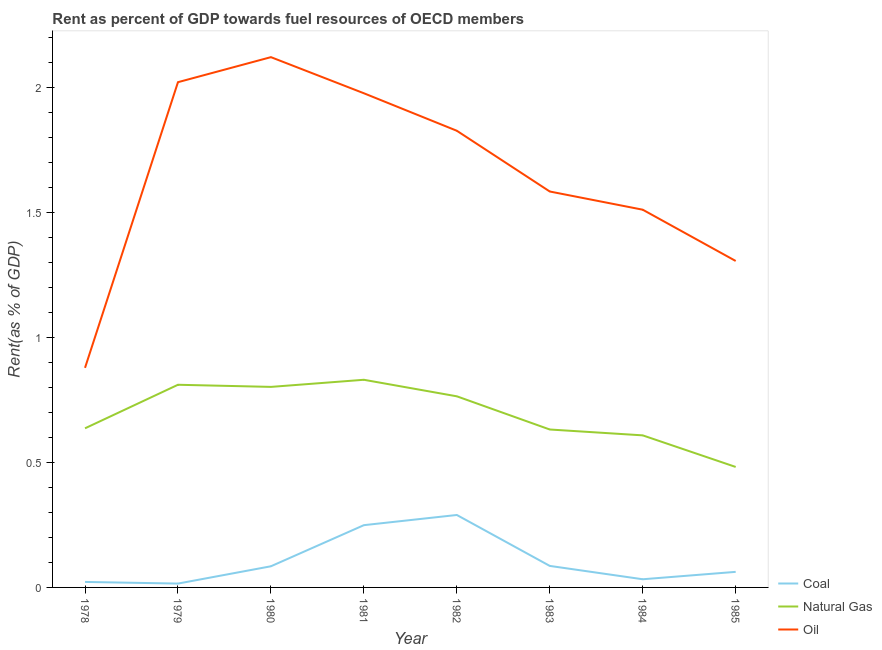Is the number of lines equal to the number of legend labels?
Offer a very short reply. Yes. What is the rent towards oil in 1979?
Offer a terse response. 2.02. Across all years, what is the maximum rent towards coal?
Offer a terse response. 0.29. Across all years, what is the minimum rent towards natural gas?
Give a very brief answer. 0.48. In which year was the rent towards coal minimum?
Ensure brevity in your answer.  1979. What is the total rent towards oil in the graph?
Give a very brief answer. 13.23. What is the difference between the rent towards coal in 1980 and that in 1982?
Provide a short and direct response. -0.21. What is the difference between the rent towards oil in 1980 and the rent towards natural gas in 1979?
Make the answer very short. 1.31. What is the average rent towards coal per year?
Keep it short and to the point. 0.11. In the year 1982, what is the difference between the rent towards coal and rent towards oil?
Give a very brief answer. -1.54. In how many years, is the rent towards natural gas greater than 0.4 %?
Your answer should be very brief. 8. What is the ratio of the rent towards natural gas in 1979 to that in 1981?
Offer a very short reply. 0.98. Is the rent towards natural gas in 1980 less than that in 1985?
Ensure brevity in your answer.  No. Is the difference between the rent towards oil in 1981 and 1983 greater than the difference between the rent towards natural gas in 1981 and 1983?
Offer a very short reply. Yes. What is the difference between the highest and the second highest rent towards coal?
Ensure brevity in your answer.  0.04. What is the difference between the highest and the lowest rent towards oil?
Keep it short and to the point. 1.24. In how many years, is the rent towards oil greater than the average rent towards oil taken over all years?
Your answer should be very brief. 4. Is the sum of the rent towards oil in 1980 and 1982 greater than the maximum rent towards coal across all years?
Your response must be concise. Yes. Is the rent towards oil strictly less than the rent towards natural gas over the years?
Your answer should be compact. No. How many lines are there?
Give a very brief answer. 3. What is the difference between two consecutive major ticks on the Y-axis?
Your answer should be compact. 0.5. Does the graph contain grids?
Your answer should be very brief. No. Where does the legend appear in the graph?
Ensure brevity in your answer.  Bottom right. How many legend labels are there?
Provide a succinct answer. 3. How are the legend labels stacked?
Make the answer very short. Vertical. What is the title of the graph?
Keep it short and to the point. Rent as percent of GDP towards fuel resources of OECD members. Does "Travel services" appear as one of the legend labels in the graph?
Ensure brevity in your answer.  No. What is the label or title of the Y-axis?
Offer a terse response. Rent(as % of GDP). What is the Rent(as % of GDP) of Coal in 1978?
Your answer should be compact. 0.02. What is the Rent(as % of GDP) of Natural Gas in 1978?
Your answer should be compact. 0.64. What is the Rent(as % of GDP) of Oil in 1978?
Ensure brevity in your answer.  0.88. What is the Rent(as % of GDP) of Coal in 1979?
Offer a terse response. 0.02. What is the Rent(as % of GDP) in Natural Gas in 1979?
Offer a terse response. 0.81. What is the Rent(as % of GDP) of Oil in 1979?
Your answer should be compact. 2.02. What is the Rent(as % of GDP) of Coal in 1980?
Offer a terse response. 0.08. What is the Rent(as % of GDP) of Natural Gas in 1980?
Provide a succinct answer. 0.8. What is the Rent(as % of GDP) of Oil in 1980?
Give a very brief answer. 2.12. What is the Rent(as % of GDP) of Coal in 1981?
Make the answer very short. 0.25. What is the Rent(as % of GDP) of Natural Gas in 1981?
Provide a short and direct response. 0.83. What is the Rent(as % of GDP) of Oil in 1981?
Provide a succinct answer. 1.98. What is the Rent(as % of GDP) of Coal in 1982?
Your answer should be compact. 0.29. What is the Rent(as % of GDP) in Natural Gas in 1982?
Your answer should be very brief. 0.76. What is the Rent(as % of GDP) of Oil in 1982?
Give a very brief answer. 1.83. What is the Rent(as % of GDP) in Coal in 1983?
Offer a very short reply. 0.09. What is the Rent(as % of GDP) in Natural Gas in 1983?
Ensure brevity in your answer.  0.63. What is the Rent(as % of GDP) of Oil in 1983?
Keep it short and to the point. 1.58. What is the Rent(as % of GDP) of Coal in 1984?
Your response must be concise. 0.03. What is the Rent(as % of GDP) of Natural Gas in 1984?
Your answer should be very brief. 0.61. What is the Rent(as % of GDP) in Oil in 1984?
Keep it short and to the point. 1.51. What is the Rent(as % of GDP) in Coal in 1985?
Make the answer very short. 0.06. What is the Rent(as % of GDP) in Natural Gas in 1985?
Your answer should be very brief. 0.48. What is the Rent(as % of GDP) of Oil in 1985?
Provide a short and direct response. 1.31. Across all years, what is the maximum Rent(as % of GDP) of Coal?
Make the answer very short. 0.29. Across all years, what is the maximum Rent(as % of GDP) in Natural Gas?
Provide a short and direct response. 0.83. Across all years, what is the maximum Rent(as % of GDP) of Oil?
Provide a succinct answer. 2.12. Across all years, what is the minimum Rent(as % of GDP) of Coal?
Your response must be concise. 0.02. Across all years, what is the minimum Rent(as % of GDP) of Natural Gas?
Make the answer very short. 0.48. Across all years, what is the minimum Rent(as % of GDP) in Oil?
Make the answer very short. 0.88. What is the total Rent(as % of GDP) in Coal in the graph?
Ensure brevity in your answer.  0.84. What is the total Rent(as % of GDP) of Natural Gas in the graph?
Provide a succinct answer. 5.57. What is the total Rent(as % of GDP) of Oil in the graph?
Provide a succinct answer. 13.23. What is the difference between the Rent(as % of GDP) in Coal in 1978 and that in 1979?
Make the answer very short. 0.01. What is the difference between the Rent(as % of GDP) of Natural Gas in 1978 and that in 1979?
Ensure brevity in your answer.  -0.17. What is the difference between the Rent(as % of GDP) of Oil in 1978 and that in 1979?
Provide a short and direct response. -1.14. What is the difference between the Rent(as % of GDP) in Coal in 1978 and that in 1980?
Your answer should be very brief. -0.06. What is the difference between the Rent(as % of GDP) in Natural Gas in 1978 and that in 1980?
Ensure brevity in your answer.  -0.17. What is the difference between the Rent(as % of GDP) of Oil in 1978 and that in 1980?
Offer a very short reply. -1.24. What is the difference between the Rent(as % of GDP) in Coal in 1978 and that in 1981?
Provide a short and direct response. -0.23. What is the difference between the Rent(as % of GDP) in Natural Gas in 1978 and that in 1981?
Your answer should be very brief. -0.19. What is the difference between the Rent(as % of GDP) in Oil in 1978 and that in 1981?
Your response must be concise. -1.1. What is the difference between the Rent(as % of GDP) in Coal in 1978 and that in 1982?
Make the answer very short. -0.27. What is the difference between the Rent(as % of GDP) of Natural Gas in 1978 and that in 1982?
Your response must be concise. -0.13. What is the difference between the Rent(as % of GDP) in Oil in 1978 and that in 1982?
Offer a very short reply. -0.95. What is the difference between the Rent(as % of GDP) of Coal in 1978 and that in 1983?
Offer a very short reply. -0.06. What is the difference between the Rent(as % of GDP) of Natural Gas in 1978 and that in 1983?
Give a very brief answer. 0. What is the difference between the Rent(as % of GDP) in Oil in 1978 and that in 1983?
Keep it short and to the point. -0.71. What is the difference between the Rent(as % of GDP) in Coal in 1978 and that in 1984?
Give a very brief answer. -0.01. What is the difference between the Rent(as % of GDP) of Natural Gas in 1978 and that in 1984?
Make the answer very short. 0.03. What is the difference between the Rent(as % of GDP) of Oil in 1978 and that in 1984?
Provide a short and direct response. -0.63. What is the difference between the Rent(as % of GDP) in Coal in 1978 and that in 1985?
Give a very brief answer. -0.04. What is the difference between the Rent(as % of GDP) in Natural Gas in 1978 and that in 1985?
Provide a short and direct response. 0.15. What is the difference between the Rent(as % of GDP) of Oil in 1978 and that in 1985?
Keep it short and to the point. -0.43. What is the difference between the Rent(as % of GDP) in Coal in 1979 and that in 1980?
Keep it short and to the point. -0.07. What is the difference between the Rent(as % of GDP) of Natural Gas in 1979 and that in 1980?
Offer a very short reply. 0.01. What is the difference between the Rent(as % of GDP) of Oil in 1979 and that in 1980?
Keep it short and to the point. -0.1. What is the difference between the Rent(as % of GDP) in Coal in 1979 and that in 1981?
Your answer should be very brief. -0.23. What is the difference between the Rent(as % of GDP) of Natural Gas in 1979 and that in 1981?
Keep it short and to the point. -0.02. What is the difference between the Rent(as % of GDP) in Oil in 1979 and that in 1981?
Provide a short and direct response. 0.04. What is the difference between the Rent(as % of GDP) of Coal in 1979 and that in 1982?
Your response must be concise. -0.27. What is the difference between the Rent(as % of GDP) of Natural Gas in 1979 and that in 1982?
Your response must be concise. 0.05. What is the difference between the Rent(as % of GDP) in Oil in 1979 and that in 1982?
Offer a very short reply. 0.19. What is the difference between the Rent(as % of GDP) in Coal in 1979 and that in 1983?
Give a very brief answer. -0.07. What is the difference between the Rent(as % of GDP) in Natural Gas in 1979 and that in 1983?
Your response must be concise. 0.18. What is the difference between the Rent(as % of GDP) of Oil in 1979 and that in 1983?
Provide a succinct answer. 0.44. What is the difference between the Rent(as % of GDP) of Coal in 1979 and that in 1984?
Offer a terse response. -0.02. What is the difference between the Rent(as % of GDP) of Natural Gas in 1979 and that in 1984?
Your answer should be very brief. 0.2. What is the difference between the Rent(as % of GDP) of Oil in 1979 and that in 1984?
Make the answer very short. 0.51. What is the difference between the Rent(as % of GDP) in Coal in 1979 and that in 1985?
Your response must be concise. -0.05. What is the difference between the Rent(as % of GDP) in Natural Gas in 1979 and that in 1985?
Provide a succinct answer. 0.33. What is the difference between the Rent(as % of GDP) of Oil in 1979 and that in 1985?
Provide a short and direct response. 0.72. What is the difference between the Rent(as % of GDP) in Coal in 1980 and that in 1981?
Make the answer very short. -0.16. What is the difference between the Rent(as % of GDP) of Natural Gas in 1980 and that in 1981?
Your answer should be compact. -0.03. What is the difference between the Rent(as % of GDP) in Oil in 1980 and that in 1981?
Your response must be concise. 0.14. What is the difference between the Rent(as % of GDP) of Coal in 1980 and that in 1982?
Provide a short and direct response. -0.21. What is the difference between the Rent(as % of GDP) of Natural Gas in 1980 and that in 1982?
Ensure brevity in your answer.  0.04. What is the difference between the Rent(as % of GDP) of Oil in 1980 and that in 1982?
Offer a very short reply. 0.29. What is the difference between the Rent(as % of GDP) in Coal in 1980 and that in 1983?
Make the answer very short. -0. What is the difference between the Rent(as % of GDP) in Natural Gas in 1980 and that in 1983?
Provide a succinct answer. 0.17. What is the difference between the Rent(as % of GDP) of Oil in 1980 and that in 1983?
Offer a very short reply. 0.54. What is the difference between the Rent(as % of GDP) in Coal in 1980 and that in 1984?
Offer a very short reply. 0.05. What is the difference between the Rent(as % of GDP) in Natural Gas in 1980 and that in 1984?
Make the answer very short. 0.19. What is the difference between the Rent(as % of GDP) of Oil in 1980 and that in 1984?
Offer a very short reply. 0.61. What is the difference between the Rent(as % of GDP) of Coal in 1980 and that in 1985?
Keep it short and to the point. 0.02. What is the difference between the Rent(as % of GDP) in Natural Gas in 1980 and that in 1985?
Make the answer very short. 0.32. What is the difference between the Rent(as % of GDP) in Oil in 1980 and that in 1985?
Provide a short and direct response. 0.82. What is the difference between the Rent(as % of GDP) in Coal in 1981 and that in 1982?
Your answer should be very brief. -0.04. What is the difference between the Rent(as % of GDP) of Natural Gas in 1981 and that in 1982?
Provide a short and direct response. 0.07. What is the difference between the Rent(as % of GDP) in Oil in 1981 and that in 1982?
Provide a succinct answer. 0.15. What is the difference between the Rent(as % of GDP) of Coal in 1981 and that in 1983?
Give a very brief answer. 0.16. What is the difference between the Rent(as % of GDP) of Natural Gas in 1981 and that in 1983?
Give a very brief answer. 0.2. What is the difference between the Rent(as % of GDP) of Oil in 1981 and that in 1983?
Keep it short and to the point. 0.39. What is the difference between the Rent(as % of GDP) of Coal in 1981 and that in 1984?
Offer a terse response. 0.22. What is the difference between the Rent(as % of GDP) of Natural Gas in 1981 and that in 1984?
Your answer should be very brief. 0.22. What is the difference between the Rent(as % of GDP) in Oil in 1981 and that in 1984?
Ensure brevity in your answer.  0.47. What is the difference between the Rent(as % of GDP) in Coal in 1981 and that in 1985?
Your answer should be very brief. 0.19. What is the difference between the Rent(as % of GDP) in Natural Gas in 1981 and that in 1985?
Your answer should be compact. 0.35. What is the difference between the Rent(as % of GDP) of Oil in 1981 and that in 1985?
Your response must be concise. 0.67. What is the difference between the Rent(as % of GDP) of Coal in 1982 and that in 1983?
Offer a very short reply. 0.2. What is the difference between the Rent(as % of GDP) in Natural Gas in 1982 and that in 1983?
Provide a succinct answer. 0.13. What is the difference between the Rent(as % of GDP) of Oil in 1982 and that in 1983?
Offer a terse response. 0.24. What is the difference between the Rent(as % of GDP) of Coal in 1982 and that in 1984?
Offer a very short reply. 0.26. What is the difference between the Rent(as % of GDP) in Natural Gas in 1982 and that in 1984?
Keep it short and to the point. 0.16. What is the difference between the Rent(as % of GDP) of Oil in 1982 and that in 1984?
Your answer should be compact. 0.32. What is the difference between the Rent(as % of GDP) of Coal in 1982 and that in 1985?
Keep it short and to the point. 0.23. What is the difference between the Rent(as % of GDP) in Natural Gas in 1982 and that in 1985?
Offer a terse response. 0.28. What is the difference between the Rent(as % of GDP) of Oil in 1982 and that in 1985?
Provide a short and direct response. 0.52. What is the difference between the Rent(as % of GDP) in Coal in 1983 and that in 1984?
Your answer should be very brief. 0.05. What is the difference between the Rent(as % of GDP) of Natural Gas in 1983 and that in 1984?
Your answer should be compact. 0.02. What is the difference between the Rent(as % of GDP) in Oil in 1983 and that in 1984?
Ensure brevity in your answer.  0.07. What is the difference between the Rent(as % of GDP) in Coal in 1983 and that in 1985?
Give a very brief answer. 0.02. What is the difference between the Rent(as % of GDP) of Natural Gas in 1983 and that in 1985?
Keep it short and to the point. 0.15. What is the difference between the Rent(as % of GDP) of Oil in 1983 and that in 1985?
Give a very brief answer. 0.28. What is the difference between the Rent(as % of GDP) in Coal in 1984 and that in 1985?
Keep it short and to the point. -0.03. What is the difference between the Rent(as % of GDP) of Natural Gas in 1984 and that in 1985?
Your response must be concise. 0.13. What is the difference between the Rent(as % of GDP) of Oil in 1984 and that in 1985?
Provide a succinct answer. 0.21. What is the difference between the Rent(as % of GDP) in Coal in 1978 and the Rent(as % of GDP) in Natural Gas in 1979?
Provide a succinct answer. -0.79. What is the difference between the Rent(as % of GDP) of Coal in 1978 and the Rent(as % of GDP) of Oil in 1979?
Your response must be concise. -2. What is the difference between the Rent(as % of GDP) of Natural Gas in 1978 and the Rent(as % of GDP) of Oil in 1979?
Give a very brief answer. -1.38. What is the difference between the Rent(as % of GDP) in Coal in 1978 and the Rent(as % of GDP) in Natural Gas in 1980?
Your response must be concise. -0.78. What is the difference between the Rent(as % of GDP) in Coal in 1978 and the Rent(as % of GDP) in Oil in 1980?
Offer a terse response. -2.1. What is the difference between the Rent(as % of GDP) of Natural Gas in 1978 and the Rent(as % of GDP) of Oil in 1980?
Provide a succinct answer. -1.49. What is the difference between the Rent(as % of GDP) of Coal in 1978 and the Rent(as % of GDP) of Natural Gas in 1981?
Provide a succinct answer. -0.81. What is the difference between the Rent(as % of GDP) of Coal in 1978 and the Rent(as % of GDP) of Oil in 1981?
Your response must be concise. -1.96. What is the difference between the Rent(as % of GDP) of Natural Gas in 1978 and the Rent(as % of GDP) of Oil in 1981?
Keep it short and to the point. -1.34. What is the difference between the Rent(as % of GDP) of Coal in 1978 and the Rent(as % of GDP) of Natural Gas in 1982?
Offer a terse response. -0.74. What is the difference between the Rent(as % of GDP) of Coal in 1978 and the Rent(as % of GDP) of Oil in 1982?
Your answer should be compact. -1.81. What is the difference between the Rent(as % of GDP) in Natural Gas in 1978 and the Rent(as % of GDP) in Oil in 1982?
Keep it short and to the point. -1.19. What is the difference between the Rent(as % of GDP) of Coal in 1978 and the Rent(as % of GDP) of Natural Gas in 1983?
Ensure brevity in your answer.  -0.61. What is the difference between the Rent(as % of GDP) of Coal in 1978 and the Rent(as % of GDP) of Oil in 1983?
Your answer should be very brief. -1.56. What is the difference between the Rent(as % of GDP) in Natural Gas in 1978 and the Rent(as % of GDP) in Oil in 1983?
Your answer should be very brief. -0.95. What is the difference between the Rent(as % of GDP) of Coal in 1978 and the Rent(as % of GDP) of Natural Gas in 1984?
Your answer should be very brief. -0.59. What is the difference between the Rent(as % of GDP) of Coal in 1978 and the Rent(as % of GDP) of Oil in 1984?
Your answer should be very brief. -1.49. What is the difference between the Rent(as % of GDP) of Natural Gas in 1978 and the Rent(as % of GDP) of Oil in 1984?
Make the answer very short. -0.87. What is the difference between the Rent(as % of GDP) of Coal in 1978 and the Rent(as % of GDP) of Natural Gas in 1985?
Make the answer very short. -0.46. What is the difference between the Rent(as % of GDP) of Coal in 1978 and the Rent(as % of GDP) of Oil in 1985?
Ensure brevity in your answer.  -1.28. What is the difference between the Rent(as % of GDP) of Natural Gas in 1978 and the Rent(as % of GDP) of Oil in 1985?
Ensure brevity in your answer.  -0.67. What is the difference between the Rent(as % of GDP) in Coal in 1979 and the Rent(as % of GDP) in Natural Gas in 1980?
Offer a terse response. -0.79. What is the difference between the Rent(as % of GDP) of Coal in 1979 and the Rent(as % of GDP) of Oil in 1980?
Your answer should be compact. -2.11. What is the difference between the Rent(as % of GDP) of Natural Gas in 1979 and the Rent(as % of GDP) of Oil in 1980?
Offer a terse response. -1.31. What is the difference between the Rent(as % of GDP) of Coal in 1979 and the Rent(as % of GDP) of Natural Gas in 1981?
Provide a succinct answer. -0.82. What is the difference between the Rent(as % of GDP) of Coal in 1979 and the Rent(as % of GDP) of Oil in 1981?
Offer a very short reply. -1.96. What is the difference between the Rent(as % of GDP) of Natural Gas in 1979 and the Rent(as % of GDP) of Oil in 1981?
Provide a short and direct response. -1.17. What is the difference between the Rent(as % of GDP) in Coal in 1979 and the Rent(as % of GDP) in Natural Gas in 1982?
Keep it short and to the point. -0.75. What is the difference between the Rent(as % of GDP) of Coal in 1979 and the Rent(as % of GDP) of Oil in 1982?
Your response must be concise. -1.81. What is the difference between the Rent(as % of GDP) in Natural Gas in 1979 and the Rent(as % of GDP) in Oil in 1982?
Offer a very short reply. -1.02. What is the difference between the Rent(as % of GDP) in Coal in 1979 and the Rent(as % of GDP) in Natural Gas in 1983?
Offer a terse response. -0.62. What is the difference between the Rent(as % of GDP) in Coal in 1979 and the Rent(as % of GDP) in Oil in 1983?
Offer a very short reply. -1.57. What is the difference between the Rent(as % of GDP) of Natural Gas in 1979 and the Rent(as % of GDP) of Oil in 1983?
Provide a short and direct response. -0.77. What is the difference between the Rent(as % of GDP) of Coal in 1979 and the Rent(as % of GDP) of Natural Gas in 1984?
Provide a short and direct response. -0.59. What is the difference between the Rent(as % of GDP) of Coal in 1979 and the Rent(as % of GDP) of Oil in 1984?
Offer a terse response. -1.5. What is the difference between the Rent(as % of GDP) in Natural Gas in 1979 and the Rent(as % of GDP) in Oil in 1984?
Your answer should be compact. -0.7. What is the difference between the Rent(as % of GDP) in Coal in 1979 and the Rent(as % of GDP) in Natural Gas in 1985?
Provide a succinct answer. -0.47. What is the difference between the Rent(as % of GDP) in Coal in 1979 and the Rent(as % of GDP) in Oil in 1985?
Give a very brief answer. -1.29. What is the difference between the Rent(as % of GDP) of Natural Gas in 1979 and the Rent(as % of GDP) of Oil in 1985?
Your response must be concise. -0.5. What is the difference between the Rent(as % of GDP) of Coal in 1980 and the Rent(as % of GDP) of Natural Gas in 1981?
Provide a succinct answer. -0.75. What is the difference between the Rent(as % of GDP) of Coal in 1980 and the Rent(as % of GDP) of Oil in 1981?
Your answer should be compact. -1.89. What is the difference between the Rent(as % of GDP) of Natural Gas in 1980 and the Rent(as % of GDP) of Oil in 1981?
Provide a short and direct response. -1.17. What is the difference between the Rent(as % of GDP) in Coal in 1980 and the Rent(as % of GDP) in Natural Gas in 1982?
Make the answer very short. -0.68. What is the difference between the Rent(as % of GDP) in Coal in 1980 and the Rent(as % of GDP) in Oil in 1982?
Offer a terse response. -1.74. What is the difference between the Rent(as % of GDP) of Natural Gas in 1980 and the Rent(as % of GDP) of Oil in 1982?
Offer a very short reply. -1.02. What is the difference between the Rent(as % of GDP) of Coal in 1980 and the Rent(as % of GDP) of Natural Gas in 1983?
Your answer should be compact. -0.55. What is the difference between the Rent(as % of GDP) in Coal in 1980 and the Rent(as % of GDP) in Oil in 1983?
Make the answer very short. -1.5. What is the difference between the Rent(as % of GDP) of Natural Gas in 1980 and the Rent(as % of GDP) of Oil in 1983?
Offer a terse response. -0.78. What is the difference between the Rent(as % of GDP) of Coal in 1980 and the Rent(as % of GDP) of Natural Gas in 1984?
Give a very brief answer. -0.52. What is the difference between the Rent(as % of GDP) in Coal in 1980 and the Rent(as % of GDP) in Oil in 1984?
Offer a terse response. -1.43. What is the difference between the Rent(as % of GDP) of Natural Gas in 1980 and the Rent(as % of GDP) of Oil in 1984?
Provide a succinct answer. -0.71. What is the difference between the Rent(as % of GDP) of Coal in 1980 and the Rent(as % of GDP) of Natural Gas in 1985?
Provide a succinct answer. -0.4. What is the difference between the Rent(as % of GDP) of Coal in 1980 and the Rent(as % of GDP) of Oil in 1985?
Keep it short and to the point. -1.22. What is the difference between the Rent(as % of GDP) of Natural Gas in 1980 and the Rent(as % of GDP) of Oil in 1985?
Give a very brief answer. -0.5. What is the difference between the Rent(as % of GDP) in Coal in 1981 and the Rent(as % of GDP) in Natural Gas in 1982?
Your response must be concise. -0.52. What is the difference between the Rent(as % of GDP) of Coal in 1981 and the Rent(as % of GDP) of Oil in 1982?
Offer a very short reply. -1.58. What is the difference between the Rent(as % of GDP) in Natural Gas in 1981 and the Rent(as % of GDP) in Oil in 1982?
Your response must be concise. -1. What is the difference between the Rent(as % of GDP) in Coal in 1981 and the Rent(as % of GDP) in Natural Gas in 1983?
Ensure brevity in your answer.  -0.38. What is the difference between the Rent(as % of GDP) of Coal in 1981 and the Rent(as % of GDP) of Oil in 1983?
Provide a short and direct response. -1.33. What is the difference between the Rent(as % of GDP) of Natural Gas in 1981 and the Rent(as % of GDP) of Oil in 1983?
Provide a short and direct response. -0.75. What is the difference between the Rent(as % of GDP) in Coal in 1981 and the Rent(as % of GDP) in Natural Gas in 1984?
Make the answer very short. -0.36. What is the difference between the Rent(as % of GDP) of Coal in 1981 and the Rent(as % of GDP) of Oil in 1984?
Your answer should be compact. -1.26. What is the difference between the Rent(as % of GDP) of Natural Gas in 1981 and the Rent(as % of GDP) of Oil in 1984?
Give a very brief answer. -0.68. What is the difference between the Rent(as % of GDP) of Coal in 1981 and the Rent(as % of GDP) of Natural Gas in 1985?
Offer a very short reply. -0.23. What is the difference between the Rent(as % of GDP) of Coal in 1981 and the Rent(as % of GDP) of Oil in 1985?
Offer a terse response. -1.06. What is the difference between the Rent(as % of GDP) of Natural Gas in 1981 and the Rent(as % of GDP) of Oil in 1985?
Ensure brevity in your answer.  -0.48. What is the difference between the Rent(as % of GDP) of Coal in 1982 and the Rent(as % of GDP) of Natural Gas in 1983?
Keep it short and to the point. -0.34. What is the difference between the Rent(as % of GDP) of Coal in 1982 and the Rent(as % of GDP) of Oil in 1983?
Offer a terse response. -1.29. What is the difference between the Rent(as % of GDP) in Natural Gas in 1982 and the Rent(as % of GDP) in Oil in 1983?
Make the answer very short. -0.82. What is the difference between the Rent(as % of GDP) of Coal in 1982 and the Rent(as % of GDP) of Natural Gas in 1984?
Keep it short and to the point. -0.32. What is the difference between the Rent(as % of GDP) of Coal in 1982 and the Rent(as % of GDP) of Oil in 1984?
Your answer should be compact. -1.22. What is the difference between the Rent(as % of GDP) in Natural Gas in 1982 and the Rent(as % of GDP) in Oil in 1984?
Your answer should be very brief. -0.75. What is the difference between the Rent(as % of GDP) in Coal in 1982 and the Rent(as % of GDP) in Natural Gas in 1985?
Your response must be concise. -0.19. What is the difference between the Rent(as % of GDP) of Coal in 1982 and the Rent(as % of GDP) of Oil in 1985?
Your response must be concise. -1.02. What is the difference between the Rent(as % of GDP) of Natural Gas in 1982 and the Rent(as % of GDP) of Oil in 1985?
Your answer should be very brief. -0.54. What is the difference between the Rent(as % of GDP) of Coal in 1983 and the Rent(as % of GDP) of Natural Gas in 1984?
Offer a terse response. -0.52. What is the difference between the Rent(as % of GDP) of Coal in 1983 and the Rent(as % of GDP) of Oil in 1984?
Keep it short and to the point. -1.43. What is the difference between the Rent(as % of GDP) in Natural Gas in 1983 and the Rent(as % of GDP) in Oil in 1984?
Keep it short and to the point. -0.88. What is the difference between the Rent(as % of GDP) in Coal in 1983 and the Rent(as % of GDP) in Natural Gas in 1985?
Give a very brief answer. -0.4. What is the difference between the Rent(as % of GDP) of Coal in 1983 and the Rent(as % of GDP) of Oil in 1985?
Offer a terse response. -1.22. What is the difference between the Rent(as % of GDP) of Natural Gas in 1983 and the Rent(as % of GDP) of Oil in 1985?
Provide a short and direct response. -0.67. What is the difference between the Rent(as % of GDP) of Coal in 1984 and the Rent(as % of GDP) of Natural Gas in 1985?
Keep it short and to the point. -0.45. What is the difference between the Rent(as % of GDP) of Coal in 1984 and the Rent(as % of GDP) of Oil in 1985?
Provide a short and direct response. -1.27. What is the difference between the Rent(as % of GDP) in Natural Gas in 1984 and the Rent(as % of GDP) in Oil in 1985?
Make the answer very short. -0.7. What is the average Rent(as % of GDP) in Coal per year?
Your response must be concise. 0.11. What is the average Rent(as % of GDP) of Natural Gas per year?
Provide a short and direct response. 0.7. What is the average Rent(as % of GDP) in Oil per year?
Provide a succinct answer. 1.65. In the year 1978, what is the difference between the Rent(as % of GDP) in Coal and Rent(as % of GDP) in Natural Gas?
Give a very brief answer. -0.61. In the year 1978, what is the difference between the Rent(as % of GDP) in Coal and Rent(as % of GDP) in Oil?
Your answer should be compact. -0.86. In the year 1978, what is the difference between the Rent(as % of GDP) in Natural Gas and Rent(as % of GDP) in Oil?
Your answer should be compact. -0.24. In the year 1979, what is the difference between the Rent(as % of GDP) in Coal and Rent(as % of GDP) in Natural Gas?
Keep it short and to the point. -0.8. In the year 1979, what is the difference between the Rent(as % of GDP) of Coal and Rent(as % of GDP) of Oil?
Provide a short and direct response. -2.01. In the year 1979, what is the difference between the Rent(as % of GDP) of Natural Gas and Rent(as % of GDP) of Oil?
Ensure brevity in your answer.  -1.21. In the year 1980, what is the difference between the Rent(as % of GDP) of Coal and Rent(as % of GDP) of Natural Gas?
Offer a very short reply. -0.72. In the year 1980, what is the difference between the Rent(as % of GDP) in Coal and Rent(as % of GDP) in Oil?
Provide a short and direct response. -2.04. In the year 1980, what is the difference between the Rent(as % of GDP) in Natural Gas and Rent(as % of GDP) in Oil?
Keep it short and to the point. -1.32. In the year 1981, what is the difference between the Rent(as % of GDP) of Coal and Rent(as % of GDP) of Natural Gas?
Offer a very short reply. -0.58. In the year 1981, what is the difference between the Rent(as % of GDP) in Coal and Rent(as % of GDP) in Oil?
Make the answer very short. -1.73. In the year 1981, what is the difference between the Rent(as % of GDP) of Natural Gas and Rent(as % of GDP) of Oil?
Offer a very short reply. -1.15. In the year 1982, what is the difference between the Rent(as % of GDP) of Coal and Rent(as % of GDP) of Natural Gas?
Your answer should be very brief. -0.47. In the year 1982, what is the difference between the Rent(as % of GDP) in Coal and Rent(as % of GDP) in Oil?
Ensure brevity in your answer.  -1.54. In the year 1982, what is the difference between the Rent(as % of GDP) of Natural Gas and Rent(as % of GDP) of Oil?
Your response must be concise. -1.06. In the year 1983, what is the difference between the Rent(as % of GDP) of Coal and Rent(as % of GDP) of Natural Gas?
Your response must be concise. -0.55. In the year 1983, what is the difference between the Rent(as % of GDP) in Coal and Rent(as % of GDP) in Oil?
Ensure brevity in your answer.  -1.5. In the year 1983, what is the difference between the Rent(as % of GDP) in Natural Gas and Rent(as % of GDP) in Oil?
Provide a succinct answer. -0.95. In the year 1984, what is the difference between the Rent(as % of GDP) of Coal and Rent(as % of GDP) of Natural Gas?
Your response must be concise. -0.58. In the year 1984, what is the difference between the Rent(as % of GDP) of Coal and Rent(as % of GDP) of Oil?
Offer a very short reply. -1.48. In the year 1984, what is the difference between the Rent(as % of GDP) of Natural Gas and Rent(as % of GDP) of Oil?
Ensure brevity in your answer.  -0.9. In the year 1985, what is the difference between the Rent(as % of GDP) of Coal and Rent(as % of GDP) of Natural Gas?
Your answer should be compact. -0.42. In the year 1985, what is the difference between the Rent(as % of GDP) of Coal and Rent(as % of GDP) of Oil?
Give a very brief answer. -1.24. In the year 1985, what is the difference between the Rent(as % of GDP) of Natural Gas and Rent(as % of GDP) of Oil?
Keep it short and to the point. -0.82. What is the ratio of the Rent(as % of GDP) of Coal in 1978 to that in 1979?
Provide a succinct answer. 1.42. What is the ratio of the Rent(as % of GDP) in Natural Gas in 1978 to that in 1979?
Give a very brief answer. 0.79. What is the ratio of the Rent(as % of GDP) of Oil in 1978 to that in 1979?
Give a very brief answer. 0.43. What is the ratio of the Rent(as % of GDP) in Coal in 1978 to that in 1980?
Provide a short and direct response. 0.26. What is the ratio of the Rent(as % of GDP) in Natural Gas in 1978 to that in 1980?
Keep it short and to the point. 0.79. What is the ratio of the Rent(as % of GDP) in Oil in 1978 to that in 1980?
Your answer should be very brief. 0.41. What is the ratio of the Rent(as % of GDP) in Coal in 1978 to that in 1981?
Make the answer very short. 0.09. What is the ratio of the Rent(as % of GDP) of Natural Gas in 1978 to that in 1981?
Offer a terse response. 0.77. What is the ratio of the Rent(as % of GDP) of Oil in 1978 to that in 1981?
Your response must be concise. 0.44. What is the ratio of the Rent(as % of GDP) of Coal in 1978 to that in 1982?
Make the answer very short. 0.08. What is the ratio of the Rent(as % of GDP) of Natural Gas in 1978 to that in 1982?
Provide a succinct answer. 0.83. What is the ratio of the Rent(as % of GDP) of Oil in 1978 to that in 1982?
Your response must be concise. 0.48. What is the ratio of the Rent(as % of GDP) in Coal in 1978 to that in 1983?
Provide a short and direct response. 0.26. What is the ratio of the Rent(as % of GDP) of Natural Gas in 1978 to that in 1983?
Offer a very short reply. 1.01. What is the ratio of the Rent(as % of GDP) in Oil in 1978 to that in 1983?
Keep it short and to the point. 0.55. What is the ratio of the Rent(as % of GDP) of Coal in 1978 to that in 1984?
Your answer should be very brief. 0.67. What is the ratio of the Rent(as % of GDP) of Natural Gas in 1978 to that in 1984?
Your answer should be very brief. 1.05. What is the ratio of the Rent(as % of GDP) in Oil in 1978 to that in 1984?
Offer a terse response. 0.58. What is the ratio of the Rent(as % of GDP) in Coal in 1978 to that in 1985?
Keep it short and to the point. 0.35. What is the ratio of the Rent(as % of GDP) in Natural Gas in 1978 to that in 1985?
Make the answer very short. 1.32. What is the ratio of the Rent(as % of GDP) of Oil in 1978 to that in 1985?
Your response must be concise. 0.67. What is the ratio of the Rent(as % of GDP) of Coal in 1979 to that in 1980?
Offer a very short reply. 0.18. What is the ratio of the Rent(as % of GDP) of Natural Gas in 1979 to that in 1980?
Provide a succinct answer. 1.01. What is the ratio of the Rent(as % of GDP) in Oil in 1979 to that in 1980?
Keep it short and to the point. 0.95. What is the ratio of the Rent(as % of GDP) of Coal in 1979 to that in 1981?
Offer a very short reply. 0.06. What is the ratio of the Rent(as % of GDP) of Oil in 1979 to that in 1981?
Offer a very short reply. 1.02. What is the ratio of the Rent(as % of GDP) in Coal in 1979 to that in 1982?
Give a very brief answer. 0.05. What is the ratio of the Rent(as % of GDP) in Natural Gas in 1979 to that in 1982?
Provide a succinct answer. 1.06. What is the ratio of the Rent(as % of GDP) of Oil in 1979 to that in 1982?
Provide a short and direct response. 1.11. What is the ratio of the Rent(as % of GDP) of Coal in 1979 to that in 1983?
Your answer should be compact. 0.18. What is the ratio of the Rent(as % of GDP) in Natural Gas in 1979 to that in 1983?
Your answer should be very brief. 1.28. What is the ratio of the Rent(as % of GDP) of Oil in 1979 to that in 1983?
Provide a succinct answer. 1.28. What is the ratio of the Rent(as % of GDP) in Coal in 1979 to that in 1984?
Offer a very short reply. 0.47. What is the ratio of the Rent(as % of GDP) of Natural Gas in 1979 to that in 1984?
Make the answer very short. 1.33. What is the ratio of the Rent(as % of GDP) of Oil in 1979 to that in 1984?
Offer a very short reply. 1.34. What is the ratio of the Rent(as % of GDP) of Coal in 1979 to that in 1985?
Your answer should be compact. 0.25. What is the ratio of the Rent(as % of GDP) of Natural Gas in 1979 to that in 1985?
Give a very brief answer. 1.68. What is the ratio of the Rent(as % of GDP) of Oil in 1979 to that in 1985?
Make the answer very short. 1.55. What is the ratio of the Rent(as % of GDP) of Coal in 1980 to that in 1981?
Offer a very short reply. 0.34. What is the ratio of the Rent(as % of GDP) of Natural Gas in 1980 to that in 1981?
Keep it short and to the point. 0.97. What is the ratio of the Rent(as % of GDP) in Oil in 1980 to that in 1981?
Keep it short and to the point. 1.07. What is the ratio of the Rent(as % of GDP) of Coal in 1980 to that in 1982?
Make the answer very short. 0.29. What is the ratio of the Rent(as % of GDP) in Natural Gas in 1980 to that in 1982?
Provide a short and direct response. 1.05. What is the ratio of the Rent(as % of GDP) of Oil in 1980 to that in 1982?
Provide a succinct answer. 1.16. What is the ratio of the Rent(as % of GDP) in Coal in 1980 to that in 1983?
Offer a very short reply. 0.98. What is the ratio of the Rent(as % of GDP) of Natural Gas in 1980 to that in 1983?
Your answer should be compact. 1.27. What is the ratio of the Rent(as % of GDP) in Oil in 1980 to that in 1983?
Offer a very short reply. 1.34. What is the ratio of the Rent(as % of GDP) of Coal in 1980 to that in 1984?
Provide a short and direct response. 2.59. What is the ratio of the Rent(as % of GDP) of Natural Gas in 1980 to that in 1984?
Provide a short and direct response. 1.32. What is the ratio of the Rent(as % of GDP) in Oil in 1980 to that in 1984?
Offer a terse response. 1.4. What is the ratio of the Rent(as % of GDP) in Coal in 1980 to that in 1985?
Provide a succinct answer. 1.36. What is the ratio of the Rent(as % of GDP) in Natural Gas in 1980 to that in 1985?
Your answer should be compact. 1.66. What is the ratio of the Rent(as % of GDP) in Oil in 1980 to that in 1985?
Provide a succinct answer. 1.62. What is the ratio of the Rent(as % of GDP) in Coal in 1981 to that in 1982?
Provide a succinct answer. 0.86. What is the ratio of the Rent(as % of GDP) in Natural Gas in 1981 to that in 1982?
Make the answer very short. 1.09. What is the ratio of the Rent(as % of GDP) of Oil in 1981 to that in 1982?
Provide a short and direct response. 1.08. What is the ratio of the Rent(as % of GDP) in Coal in 1981 to that in 1983?
Keep it short and to the point. 2.89. What is the ratio of the Rent(as % of GDP) in Natural Gas in 1981 to that in 1983?
Provide a short and direct response. 1.31. What is the ratio of the Rent(as % of GDP) in Oil in 1981 to that in 1983?
Provide a succinct answer. 1.25. What is the ratio of the Rent(as % of GDP) of Coal in 1981 to that in 1984?
Provide a succinct answer. 7.62. What is the ratio of the Rent(as % of GDP) in Natural Gas in 1981 to that in 1984?
Make the answer very short. 1.37. What is the ratio of the Rent(as % of GDP) in Oil in 1981 to that in 1984?
Ensure brevity in your answer.  1.31. What is the ratio of the Rent(as % of GDP) of Coal in 1981 to that in 1985?
Provide a succinct answer. 4. What is the ratio of the Rent(as % of GDP) of Natural Gas in 1981 to that in 1985?
Make the answer very short. 1.72. What is the ratio of the Rent(as % of GDP) of Oil in 1981 to that in 1985?
Your answer should be compact. 1.51. What is the ratio of the Rent(as % of GDP) in Coal in 1982 to that in 1983?
Offer a terse response. 3.37. What is the ratio of the Rent(as % of GDP) of Natural Gas in 1982 to that in 1983?
Ensure brevity in your answer.  1.21. What is the ratio of the Rent(as % of GDP) in Oil in 1982 to that in 1983?
Offer a very short reply. 1.15. What is the ratio of the Rent(as % of GDP) in Coal in 1982 to that in 1984?
Keep it short and to the point. 8.87. What is the ratio of the Rent(as % of GDP) of Natural Gas in 1982 to that in 1984?
Provide a short and direct response. 1.26. What is the ratio of the Rent(as % of GDP) of Oil in 1982 to that in 1984?
Offer a terse response. 1.21. What is the ratio of the Rent(as % of GDP) of Coal in 1982 to that in 1985?
Ensure brevity in your answer.  4.65. What is the ratio of the Rent(as % of GDP) in Natural Gas in 1982 to that in 1985?
Your response must be concise. 1.59. What is the ratio of the Rent(as % of GDP) of Oil in 1982 to that in 1985?
Provide a succinct answer. 1.4. What is the ratio of the Rent(as % of GDP) of Coal in 1983 to that in 1984?
Keep it short and to the point. 2.63. What is the ratio of the Rent(as % of GDP) of Natural Gas in 1983 to that in 1984?
Your answer should be compact. 1.04. What is the ratio of the Rent(as % of GDP) in Oil in 1983 to that in 1984?
Your response must be concise. 1.05. What is the ratio of the Rent(as % of GDP) in Coal in 1983 to that in 1985?
Your answer should be compact. 1.38. What is the ratio of the Rent(as % of GDP) in Natural Gas in 1983 to that in 1985?
Your response must be concise. 1.31. What is the ratio of the Rent(as % of GDP) in Oil in 1983 to that in 1985?
Provide a short and direct response. 1.21. What is the ratio of the Rent(as % of GDP) of Coal in 1984 to that in 1985?
Provide a succinct answer. 0.52. What is the ratio of the Rent(as % of GDP) of Natural Gas in 1984 to that in 1985?
Provide a short and direct response. 1.26. What is the ratio of the Rent(as % of GDP) in Oil in 1984 to that in 1985?
Your answer should be very brief. 1.16. What is the difference between the highest and the second highest Rent(as % of GDP) in Coal?
Provide a short and direct response. 0.04. What is the difference between the highest and the second highest Rent(as % of GDP) in Natural Gas?
Provide a short and direct response. 0.02. What is the difference between the highest and the second highest Rent(as % of GDP) of Oil?
Keep it short and to the point. 0.1. What is the difference between the highest and the lowest Rent(as % of GDP) of Coal?
Your answer should be compact. 0.27. What is the difference between the highest and the lowest Rent(as % of GDP) of Natural Gas?
Provide a succinct answer. 0.35. What is the difference between the highest and the lowest Rent(as % of GDP) of Oil?
Your response must be concise. 1.24. 